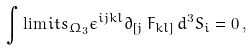<formula> <loc_0><loc_0><loc_500><loc_500>\int \lim i t s _ { \Omega _ { 3 } } \epsilon ^ { i j k l } \partial _ { [ j } \, F _ { k l ] } \, d ^ { 3 } S _ { i } = 0 \, ,</formula> 